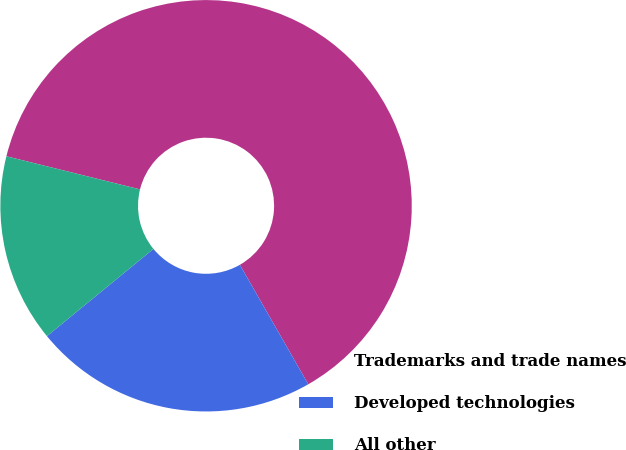Convert chart. <chart><loc_0><loc_0><loc_500><loc_500><pie_chart><fcel>Trademarks and trade names<fcel>Developed technologies<fcel>All other<nl><fcel>62.85%<fcel>22.35%<fcel>14.79%<nl></chart> 